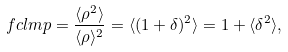<formula> <loc_0><loc_0><loc_500><loc_500>\ f c l m p = \frac { \langle \rho ^ { 2 } \rangle } { \langle \rho \rangle ^ { 2 } } = \langle ( 1 + \delta ) ^ { 2 } \rangle = 1 + \langle \delta ^ { 2 } \rangle ,</formula> 